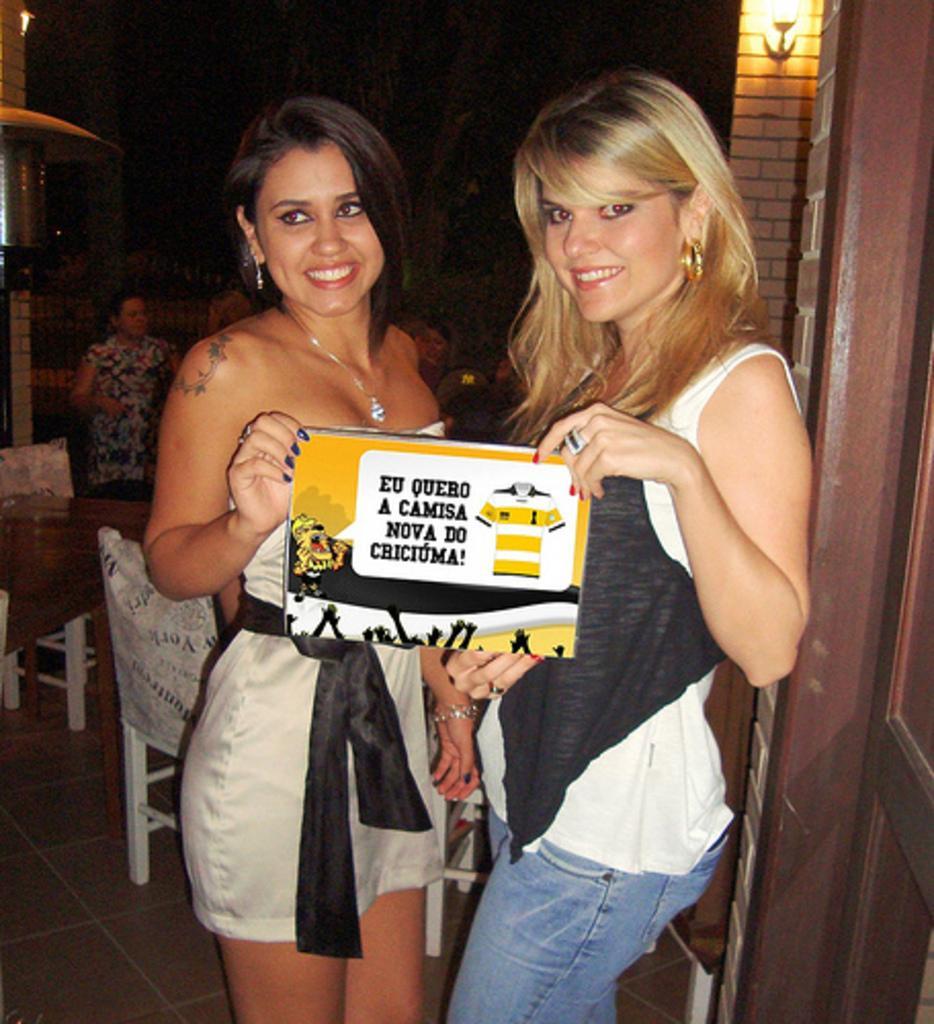How would you summarize this image in a sentence or two? In the picture we can see two women standing near the door and holding some card in the hand with some advertisement on it and in the background, we can see some chairs and some people near it and we can see a light on the wall. 